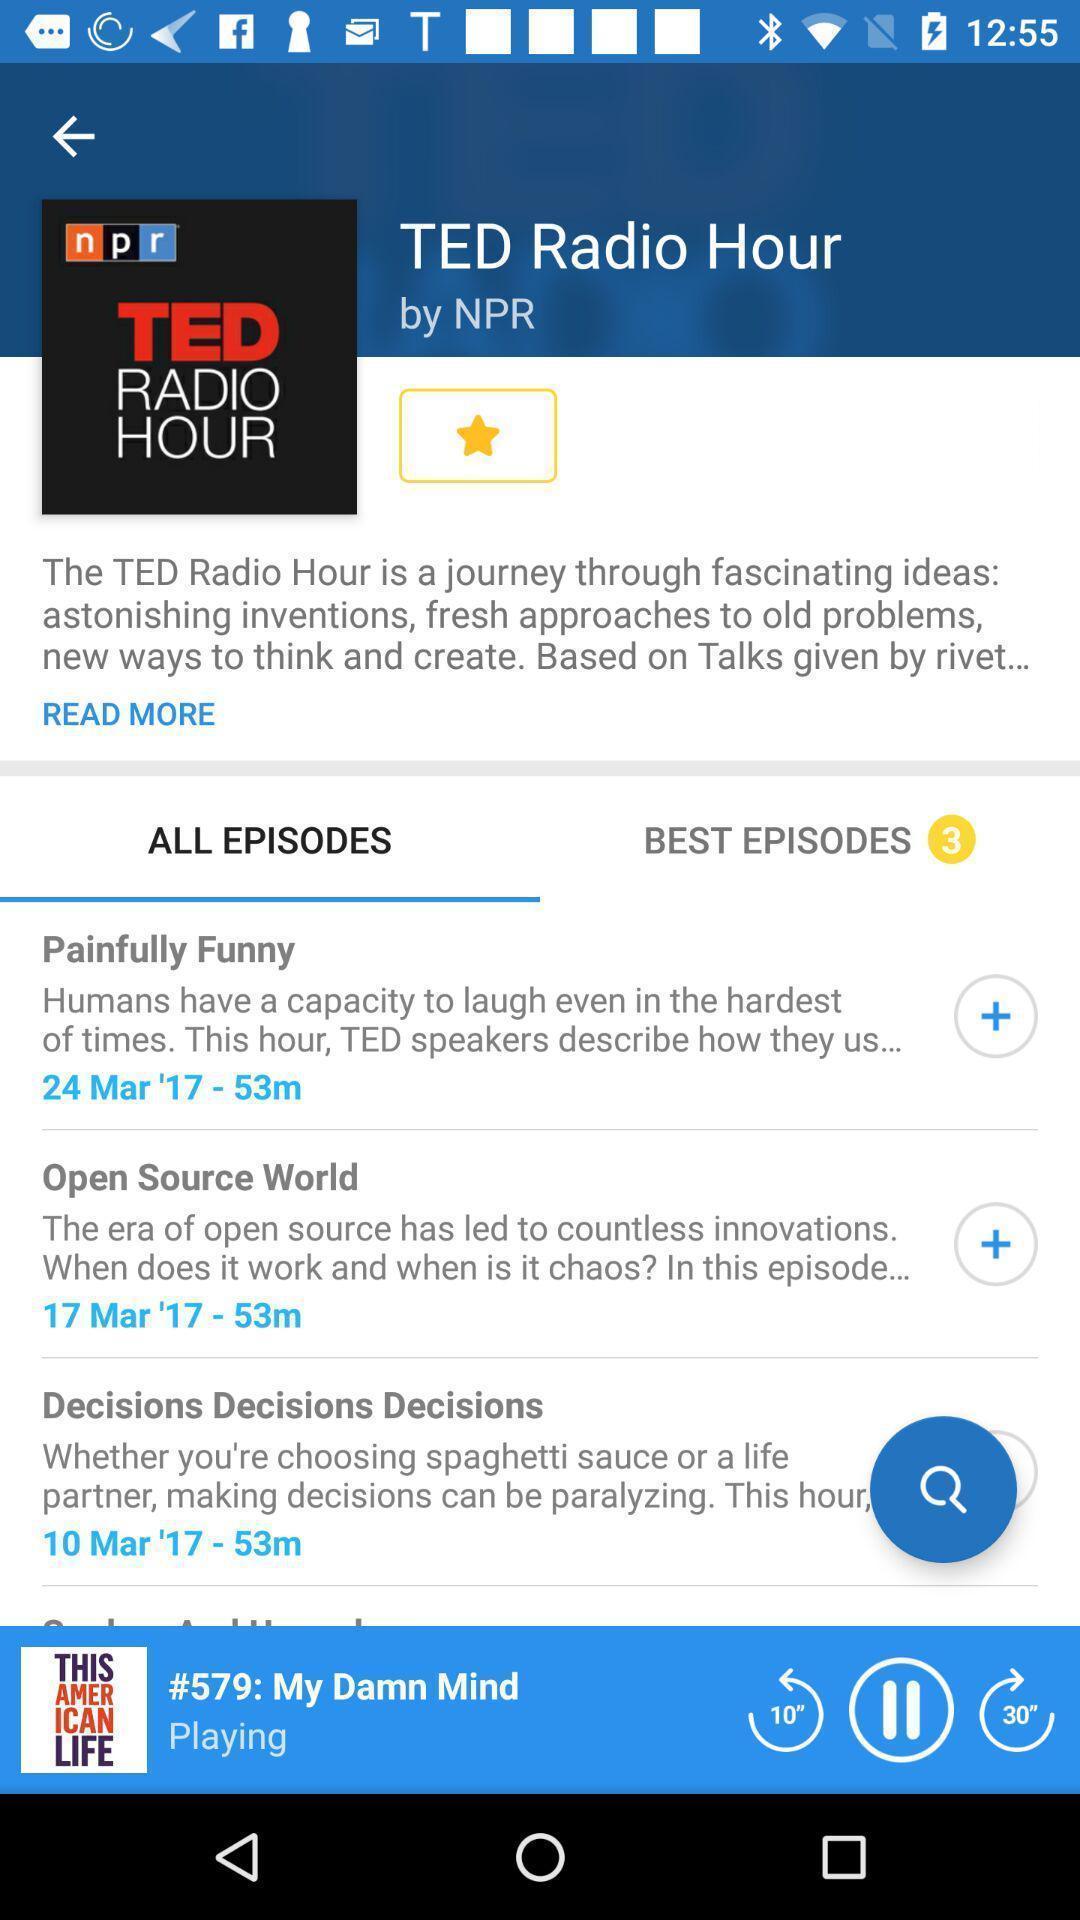What details can you identify in this image? Screen displaying all episodes of radio talk app. 